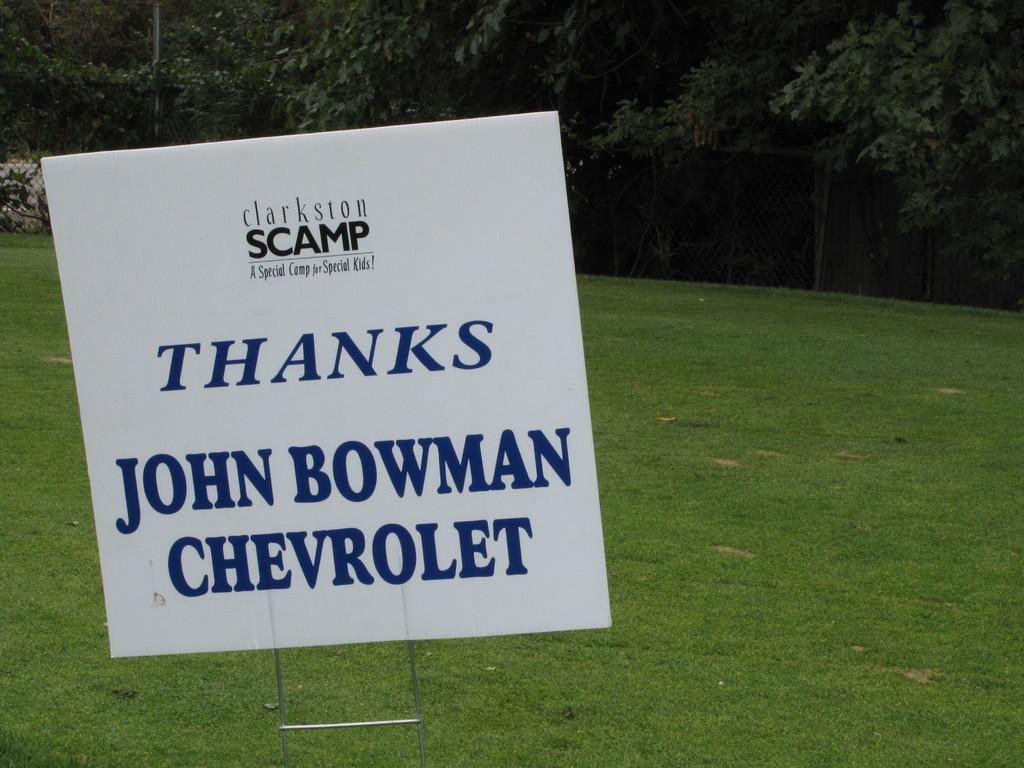What is the main object in the image? There is a whiteboard in the image. What can be seen written on the whiteboard? Something is written on the whiteboard using blue and black colors. What can be seen in the background of the image? There are trees, fencing, and a pole visible in the background of the image. What time of day is it in the image, and is there a police officer present? The time of day cannot be determined from the image, and there is no police officer present. What thought is being expressed by the person who wrote on the whiteboard? The image does not provide any information about the thoughts of the person who wrote on the whiteboard. 